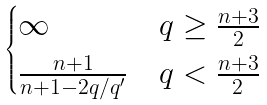<formula> <loc_0><loc_0><loc_500><loc_500>\begin{cases} \infty & q \geq \frac { n + 3 } { 2 } \\ \frac { n + 1 } { n + 1 - 2 q / q ^ { \prime } } & q < \frac { n + 3 } { 2 } \end{cases}</formula> 